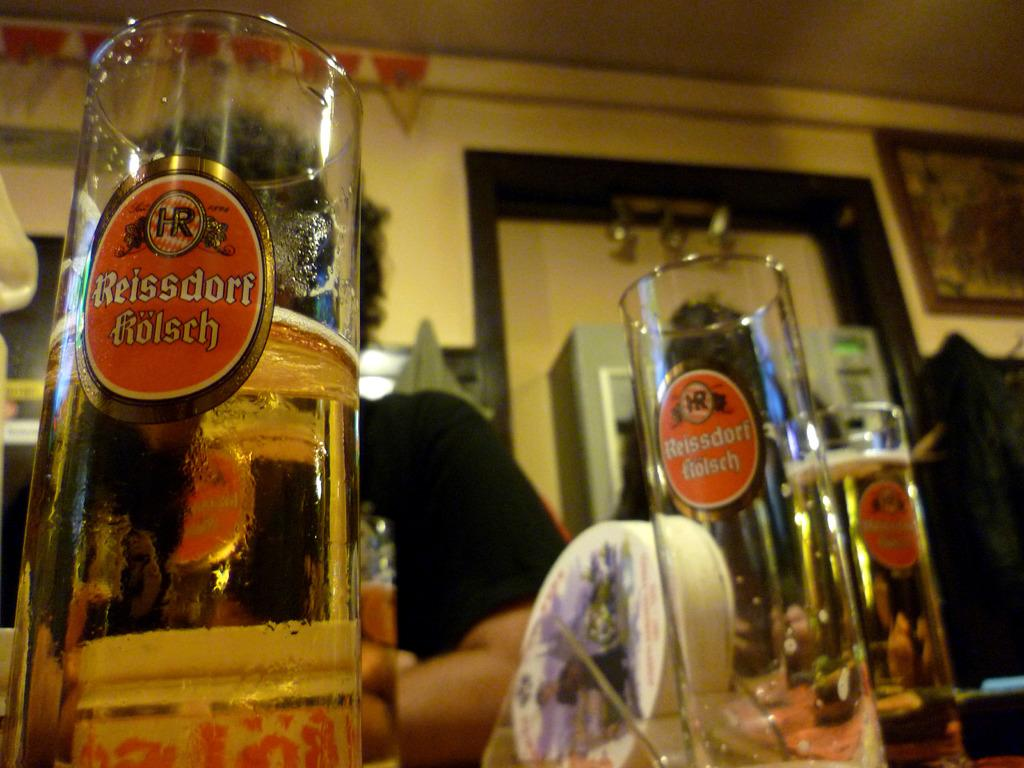Provide a one-sentence caption for the provided image. One Reissdorf kolsch glass is empty but the other two are full or almost full. 